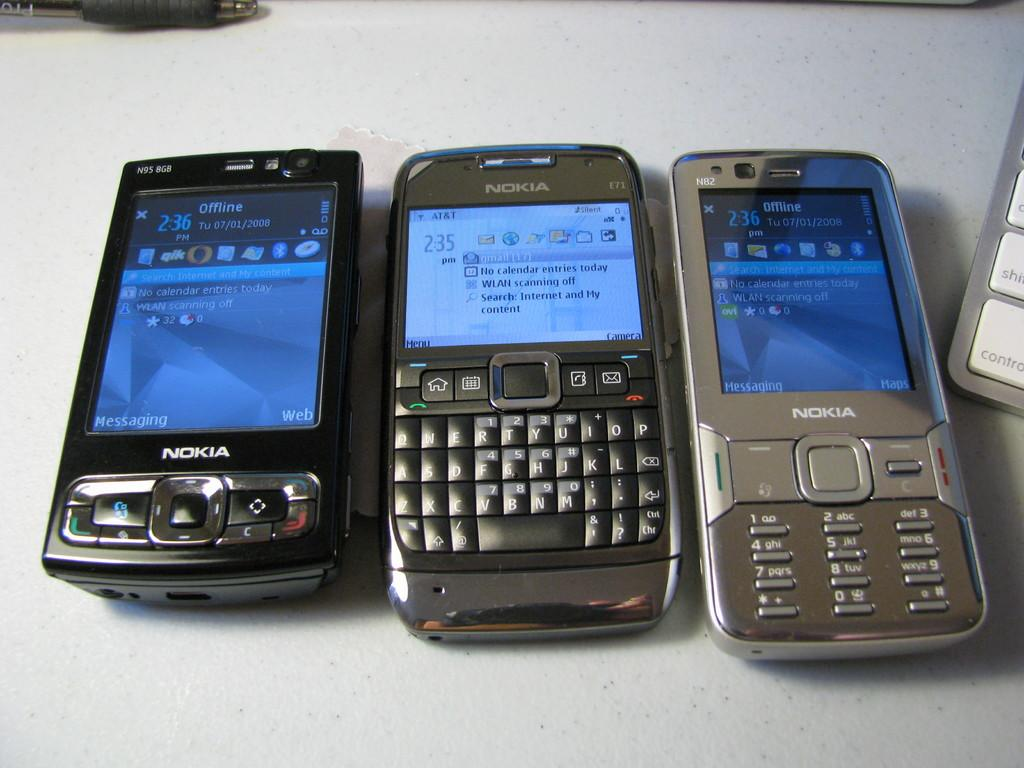<image>
Write a terse but informative summary of the picture. old smart phone nokia style phone 3 of them lined up 